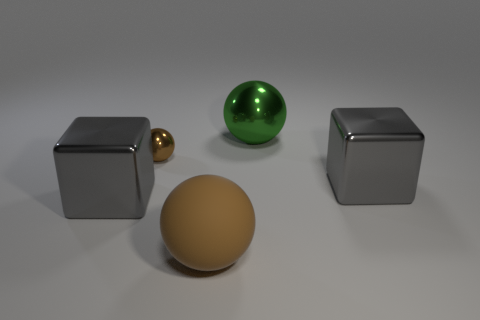How many other things are there of the same shape as the big brown rubber thing?
Offer a very short reply. 2. What shape is the thing that is both in front of the small brown metallic ball and on the left side of the brown rubber sphere?
Provide a short and direct response. Cube. The cube to the left of the block right of the big brown rubber object that is in front of the green metallic object is what color?
Your answer should be compact. Gray. Is the number of cubes on the left side of the big shiny sphere greater than the number of large gray objects behind the small brown shiny ball?
Your answer should be compact. Yes. What number of other objects are the same size as the brown shiny ball?
Make the answer very short. 0. There is another matte object that is the same color as the tiny thing; what is its size?
Your answer should be compact. Large. What is the material of the big cube left of the gray object on the right side of the large brown matte ball?
Give a very brief answer. Metal. Are there any large blocks on the right side of the large brown rubber ball?
Your answer should be very brief. Yes. Are there more tiny brown balls behind the big rubber thing than large gray shiny cylinders?
Provide a succinct answer. Yes. Are there any big balls that have the same color as the small object?
Your answer should be compact. Yes. 